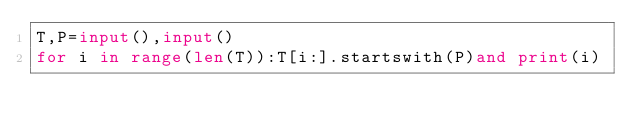<code> <loc_0><loc_0><loc_500><loc_500><_Python_>T,P=input(),input()
for i in range(len(T)):T[i:].startswith(P)and print(i)
</code> 